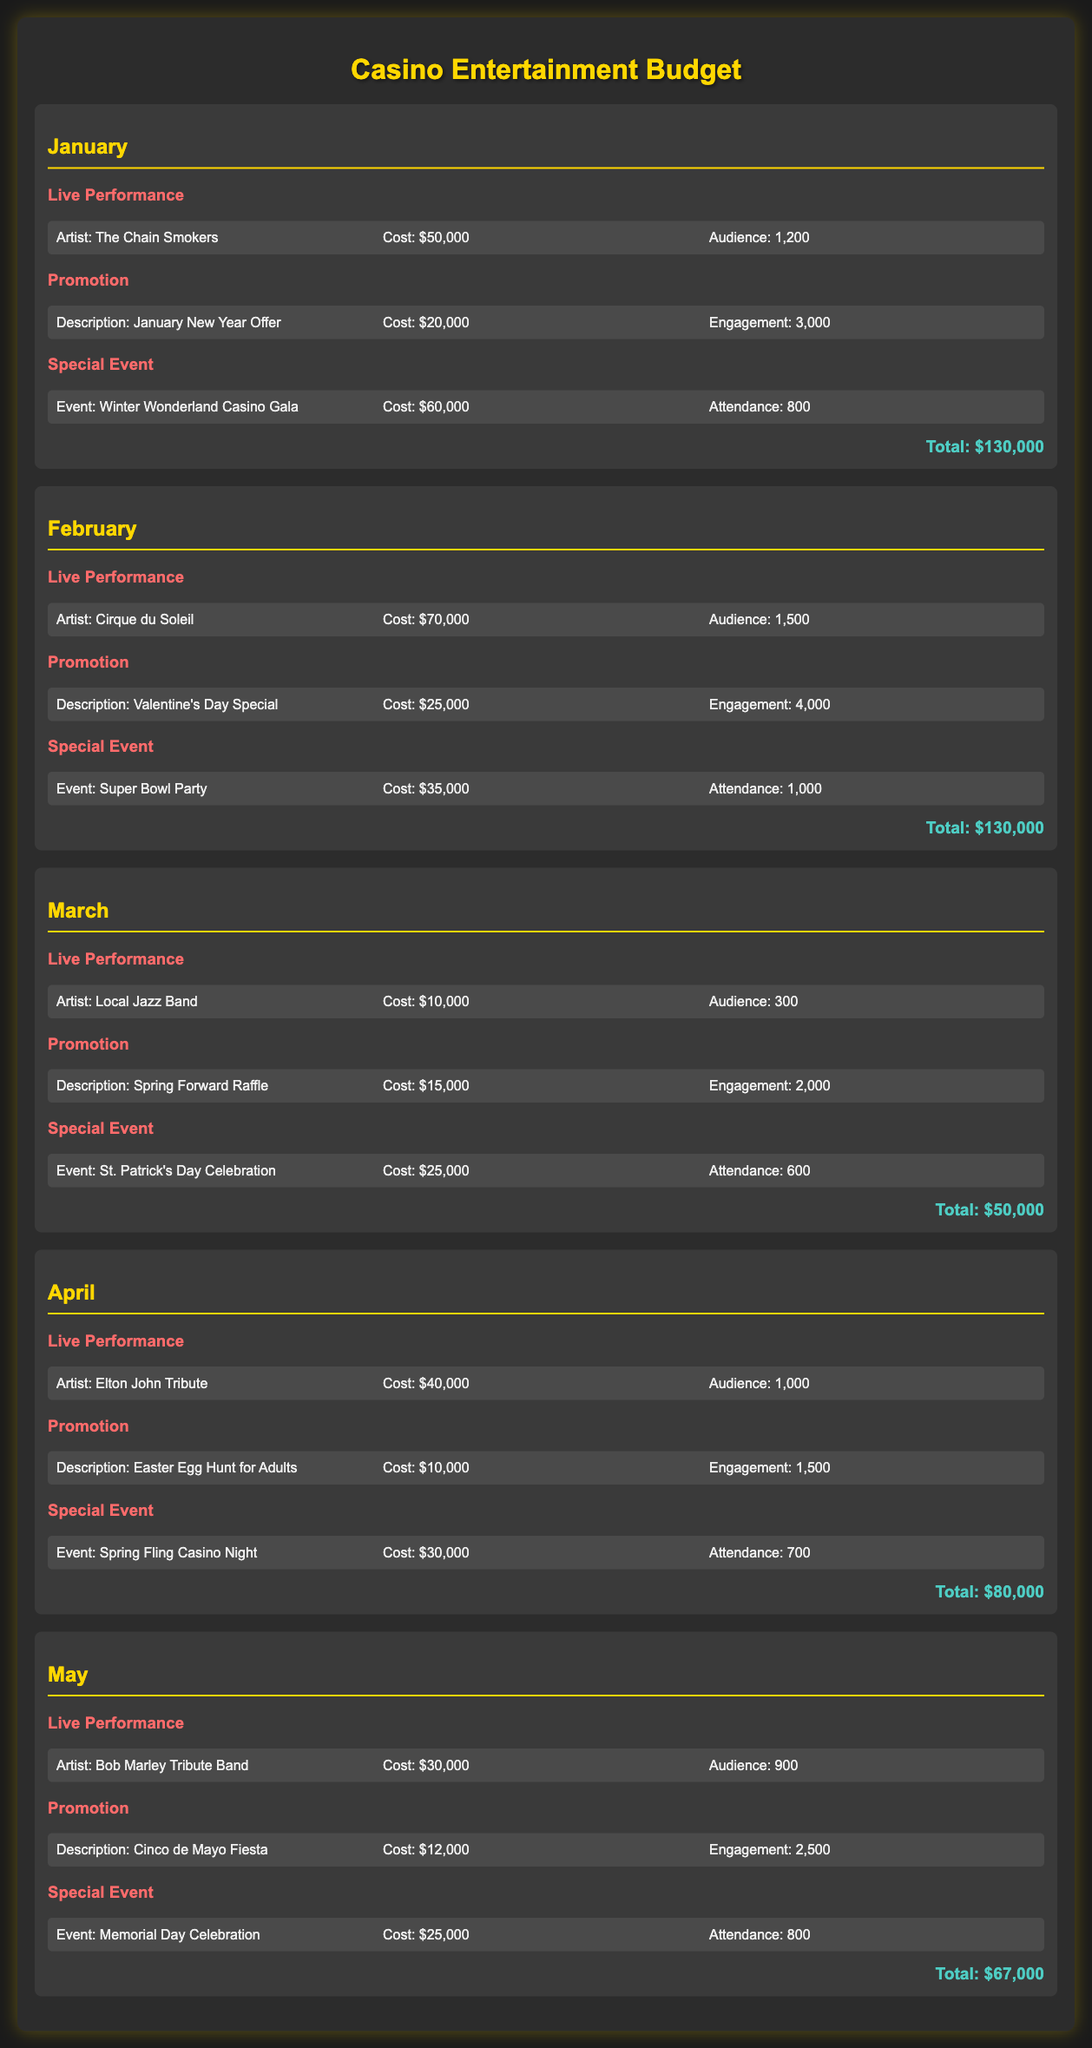What is the total cost for January? The total cost for January is presented at the end of the month section, which is $130,000.
Answer: $130,000 Who performed live in February? The document lists the artist for the live performance in February as Cirque du Soleil.
Answer: Cirque du Soleil What is the attendance at the Winter Wonderland Casino Gala? The attendance figure for the Winter Wonderland Casino Gala, as noted, is 800.
Answer: 800 What event took place in March? The special event that occurred in March is the St. Patrick's Day Celebration.
Answer: St. Patrick's Day Celebration Which month had the lowest total entertainment cost? By comparing the totals for each month, March had the lowest total entertainment cost of $50,000.
Answer: March What is the cost of the Valentines Day Special promotion? The cost for the Valentine's Day Special promotion in February is indicated as $25,000.
Answer: $25,000 How many people attended the Super Bowl Party? The attendance for the Super Bowl Party event in February is specified as 1,000.
Answer: 1,000 Who was the artist featured in the live performance for April? The artist for the live performance in April is listed as the Elton John Tribute.
Answer: Elton John Tribute What is the engagement figure for the Spring Forward Raffle promotion? The document states that the engagement figure for the Spring Forward Raffle promotion in March is 2,000.
Answer: 2,000 